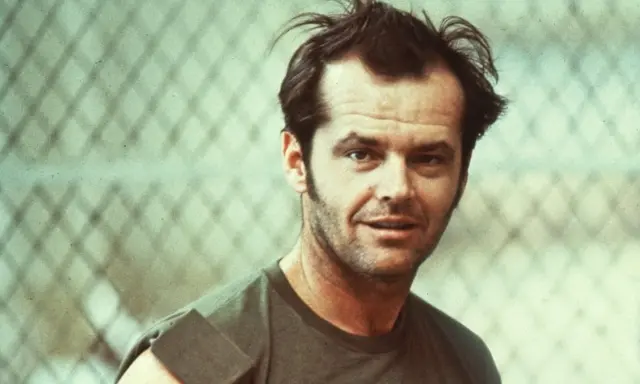What emotions do you think the person in this image is experiencing? The individual appears contemplative and intense. The serious expression and direct gaze might suggest he is deep in thought, possibly reflecting on a significant matter or moment in his life. His casual yet rugged appearance adds an air of resilience and toughness. 